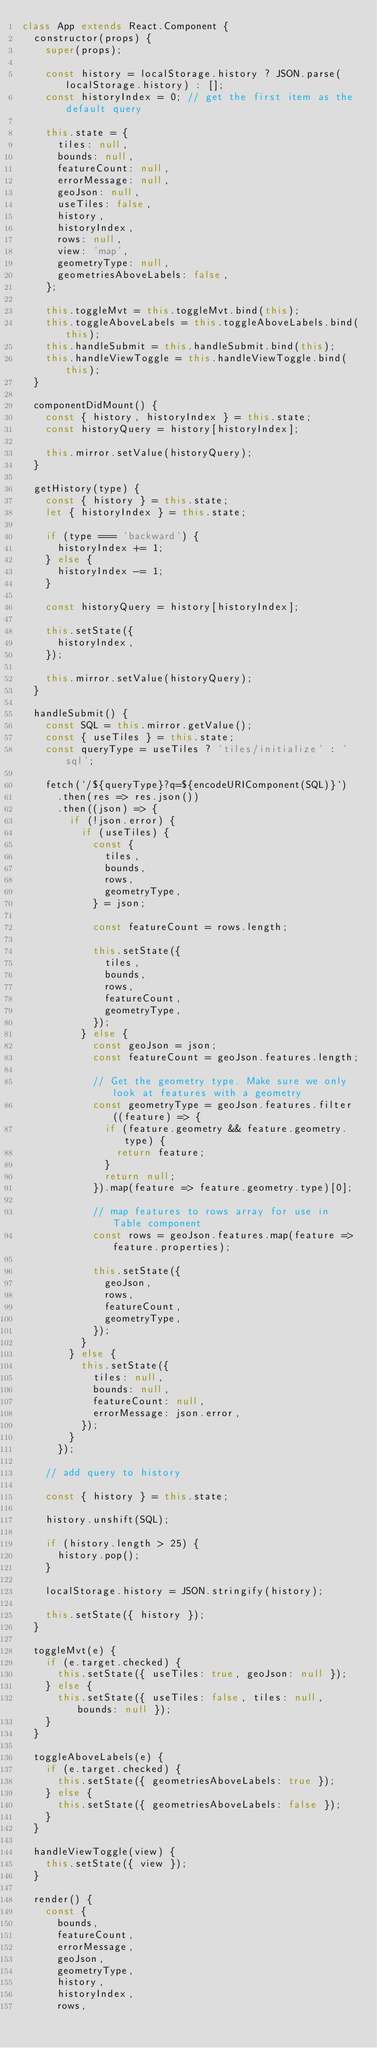Convert code to text. <code><loc_0><loc_0><loc_500><loc_500><_JavaScript_>class App extends React.Component {
  constructor(props) {
    super(props);

    const history = localStorage.history ? JSON.parse(localStorage.history) : [];
    const historyIndex = 0; // get the first item as the default query

    this.state = {
      tiles: null,
      bounds: null,
      featureCount: null,
      errorMessage: null,
      geoJson: null,
      useTiles: false,
      history,
      historyIndex,
      rows: null,
      view: 'map',
      geometryType: null,
      geometriesAboveLabels: false,
    };

    this.toggleMvt = this.toggleMvt.bind(this);
    this.toggleAboveLabels = this.toggleAboveLabels.bind(this);
    this.handleSubmit = this.handleSubmit.bind(this);
    this.handleViewToggle = this.handleViewToggle.bind(this);
  }

  componentDidMount() {
    const { history, historyIndex } = this.state;
    const historyQuery = history[historyIndex];

    this.mirror.setValue(historyQuery);
  }

  getHistory(type) {
    const { history } = this.state;
    let { historyIndex } = this.state;

    if (type === 'backward') {
      historyIndex += 1;
    } else {
      historyIndex -= 1;
    }

    const historyQuery = history[historyIndex];

    this.setState({
      historyIndex,
    });

    this.mirror.setValue(historyQuery);
  }

  handleSubmit() {
    const SQL = this.mirror.getValue();
    const { useTiles } = this.state;
    const queryType = useTiles ? 'tiles/initialize' : 'sql';

    fetch(`/${queryType}?q=${encodeURIComponent(SQL)}`)
      .then(res => res.json())
      .then((json) => {
        if (!json.error) {
          if (useTiles) {
            const {
              tiles,
              bounds,
              rows,
              geometryType,
            } = json;

            const featureCount = rows.length;

            this.setState({
              tiles,
              bounds,
              rows,
              featureCount,
              geometryType,
            });
          } else {
            const geoJson = json;
            const featureCount = geoJson.features.length;

            // Get the geometry type. Make sure we only look at features with a geometry
            const geometryType = geoJson.features.filter((feature) => {
              if (feature.geometry && feature.geometry.type) {
                return feature;
              }
              return null;
            }).map(feature => feature.geometry.type)[0];

            // map features to rows array for use in Table component
            const rows = geoJson.features.map(feature => feature.properties);

            this.setState({
              geoJson,
              rows,
              featureCount,
              geometryType,
            });
          }
        } else {
          this.setState({
            tiles: null,
            bounds: null,
            featureCount: null,
            errorMessage: json.error,
          });
        }
      });

    // add query to history

    const { history } = this.state;

    history.unshift(SQL);

    if (history.length > 25) {
      history.pop();
    }

    localStorage.history = JSON.stringify(history);

    this.setState({ history });
  }

  toggleMvt(e) {
    if (e.target.checked) {
      this.setState({ useTiles: true, geoJson: null });
    } else {
      this.setState({ useTiles: false, tiles: null, bounds: null });
    }
  }

  toggleAboveLabels(e) {
    if (e.target.checked) {
      this.setState({ geometriesAboveLabels: true });
    } else {
      this.setState({ geometriesAboveLabels: false });
    }
  }

  handleViewToggle(view) {
    this.setState({ view });
  }

  render() {
    const {
      bounds,
      featureCount,
      errorMessage,
      geoJson,
      geometryType,
      history,
      historyIndex,
      rows,</code> 